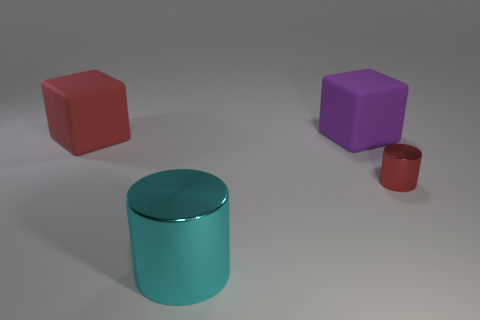What number of things are either things that are on the right side of the purple cube or large yellow metal objects?
Keep it short and to the point. 1. What number of other things are there of the same shape as the cyan metal thing?
Your answer should be compact. 1. Are there more red metal objects that are in front of the tiny red object than large cyan rubber cylinders?
Keep it short and to the point. No. What is the size of the cyan metallic object that is the same shape as the tiny red metal thing?
Ensure brevity in your answer.  Large. Are there any other things that have the same material as the big cyan thing?
Offer a terse response. Yes. The tiny red object has what shape?
Make the answer very short. Cylinder. There is a purple matte object that is the same size as the cyan thing; what shape is it?
Provide a short and direct response. Cube. Are there any other things that are the same color as the small metal object?
Provide a succinct answer. Yes. The object that is the same material as the red cube is what size?
Give a very brief answer. Large. Do the large cyan object and the metallic object behind the large cylinder have the same shape?
Your answer should be very brief. Yes. 